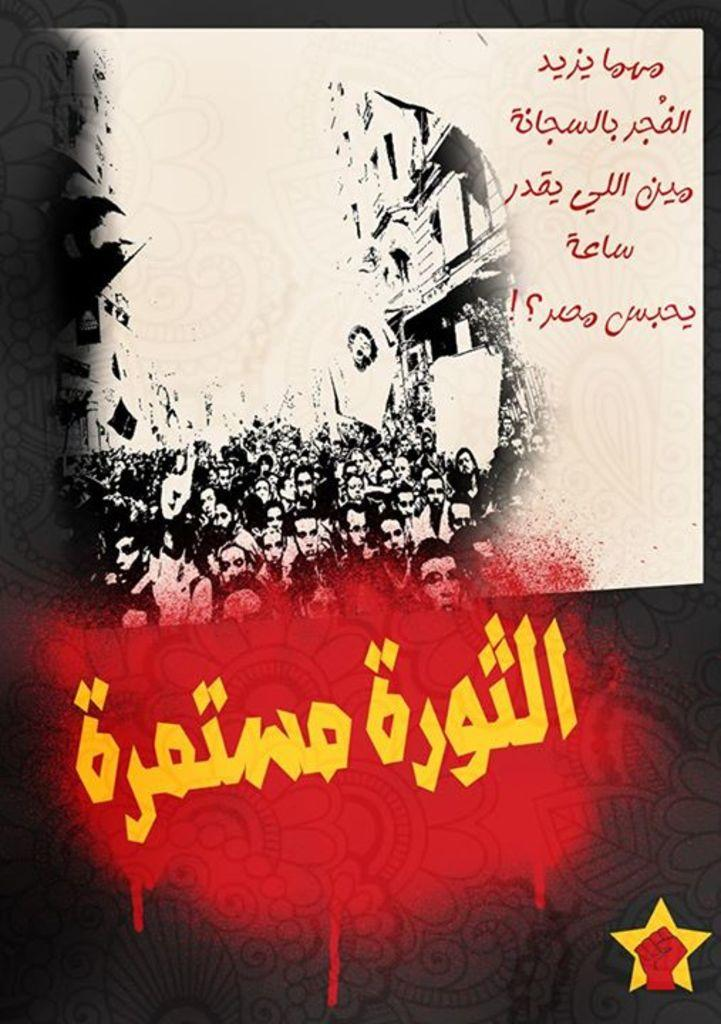What is featured on the poster in the image? There is a poster in the image that contains images of people. What else can be found on the poster besides the images of people? There is text and symbols on the poster. How many quarters can be seen on the poster? There are no quarters present on the poster; it contains images of people, text, and symbols. 